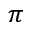<formula> <loc_0><loc_0><loc_500><loc_500>\pi</formula> 